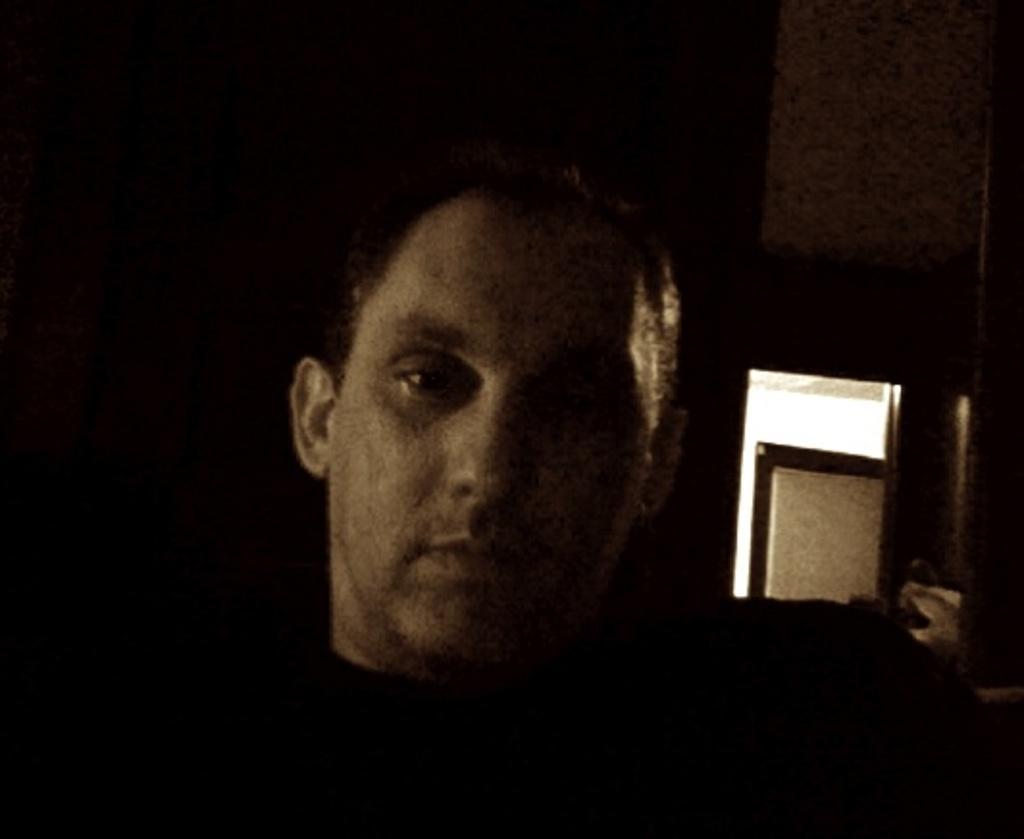Can you describe this image briefly? In this image in the foreground there is one person, and in the background there is a wall and door. 